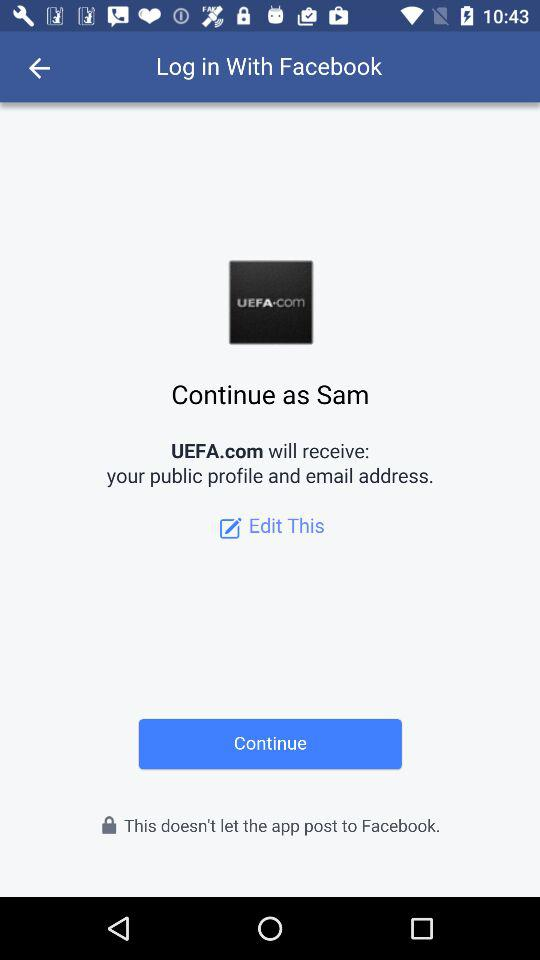What application will receive a public profile and email address? The application is "UEFA.com". 